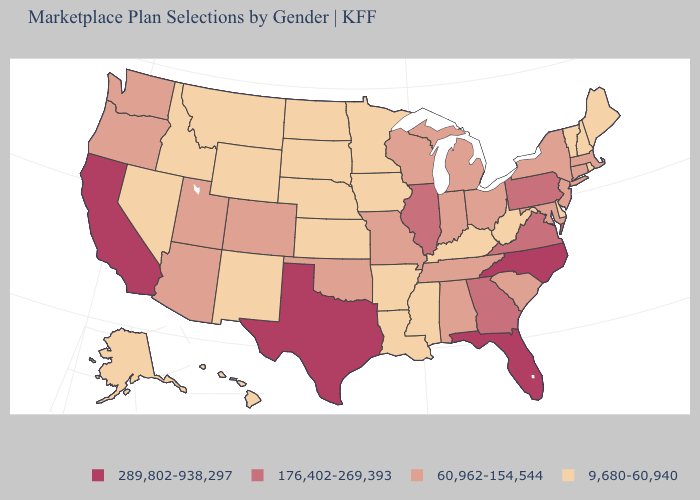Does the map have missing data?
Answer briefly. No. Name the states that have a value in the range 289,802-938,297?
Be succinct. California, Florida, North Carolina, Texas. Which states have the highest value in the USA?
Be succinct. California, Florida, North Carolina, Texas. What is the value of Mississippi?
Be succinct. 9,680-60,940. Among the states that border Indiana , which have the highest value?
Give a very brief answer. Illinois. Name the states that have a value in the range 60,962-154,544?
Short answer required. Alabama, Arizona, Colorado, Connecticut, Indiana, Maryland, Massachusetts, Michigan, Missouri, New Jersey, New York, Ohio, Oklahoma, Oregon, South Carolina, Tennessee, Utah, Washington, Wisconsin. What is the value of Mississippi?
Short answer required. 9,680-60,940. Among the states that border Wisconsin , does Iowa have the lowest value?
Quick response, please. Yes. Name the states that have a value in the range 289,802-938,297?
Concise answer only. California, Florida, North Carolina, Texas. Does North Carolina have the same value as California?
Concise answer only. Yes. What is the lowest value in the South?
Be succinct. 9,680-60,940. Which states hav the highest value in the West?
Give a very brief answer. California. Does New York have the lowest value in the Northeast?
Short answer required. No. Name the states that have a value in the range 60,962-154,544?
Write a very short answer. Alabama, Arizona, Colorado, Connecticut, Indiana, Maryland, Massachusetts, Michigan, Missouri, New Jersey, New York, Ohio, Oklahoma, Oregon, South Carolina, Tennessee, Utah, Washington, Wisconsin. Name the states that have a value in the range 289,802-938,297?
Short answer required. California, Florida, North Carolina, Texas. 